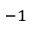Convert formula to latex. <formula><loc_0><loc_0><loc_500><loc_500>^ { - 1 }</formula> 